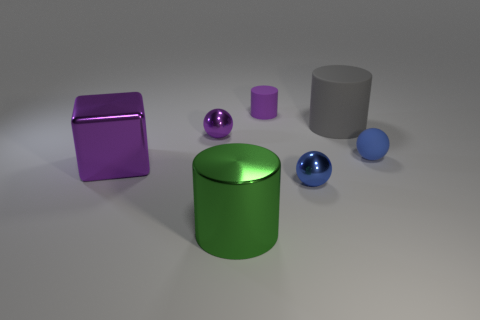What colors are predominant in this image? The predominant colors in this image are shades of purple, green, and blue. The purple color is featured in the large block and the small cylinder, blue is present in two spheres of different sizes, and green is the color of the large cylinder. 